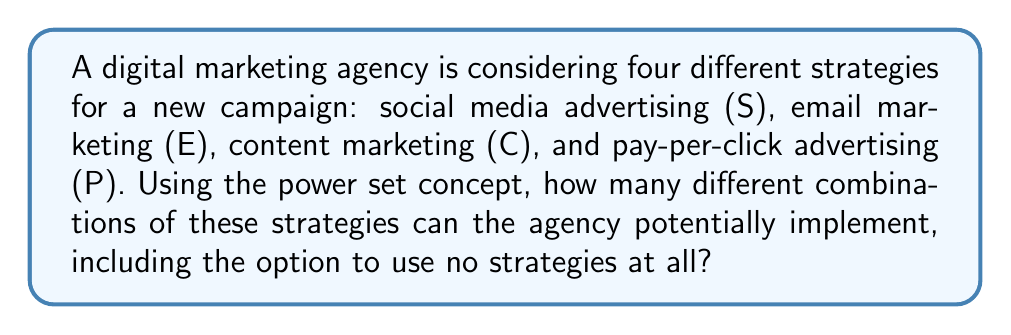Teach me how to tackle this problem. To solve this problem, we need to understand the concept of power sets and how it applies to digital marketing strategies.

1. First, let's define our set of strategies:
   $A = \{S, E, C, P\}$

2. The power set of A, denoted as $P(A)$, is the set of all possible subsets of A, including the empty set $\emptyset$ and A itself.

3. For a set with $n$ elements, the number of subsets in its power set is given by $2^n$. This is because for each element, we have two choices: include it in the subset or not.

4. In our case, we have 4 strategies, so $n = 4$.

5. Therefore, the number of possible combinations is:
   $$2^4 = 2 \times 2 \times 2 \times 2 = 16$$

6. To verify, we can list all possible combinations:
   - $\emptyset$ (no strategies)
   - $\{S\}, \{E\}, \{C\}, \{P\}$ (single strategies)
   - $\{S,E\}, \{S,C\}, \{S,P\}, \{E,C\}, \{E,P\}, \{C,P\}$ (pairs of strategies)
   - $\{S,E,C\}, \{S,E,P\}, \{S,C,P\}, \{E,C,P\}$ (triples of strategies)
   - $\{S,E,C,P\}$ (all strategies)

This power set analysis allows the digital marketing agency to consider all possible combinations of strategies, from using no strategies at all to implementing all four simultaneously. This comprehensive approach can help in decision-making and strategy optimization for the digital transformation campaign.
Answer: The agency can potentially implement 16 different combinations of digital marketing strategies. 